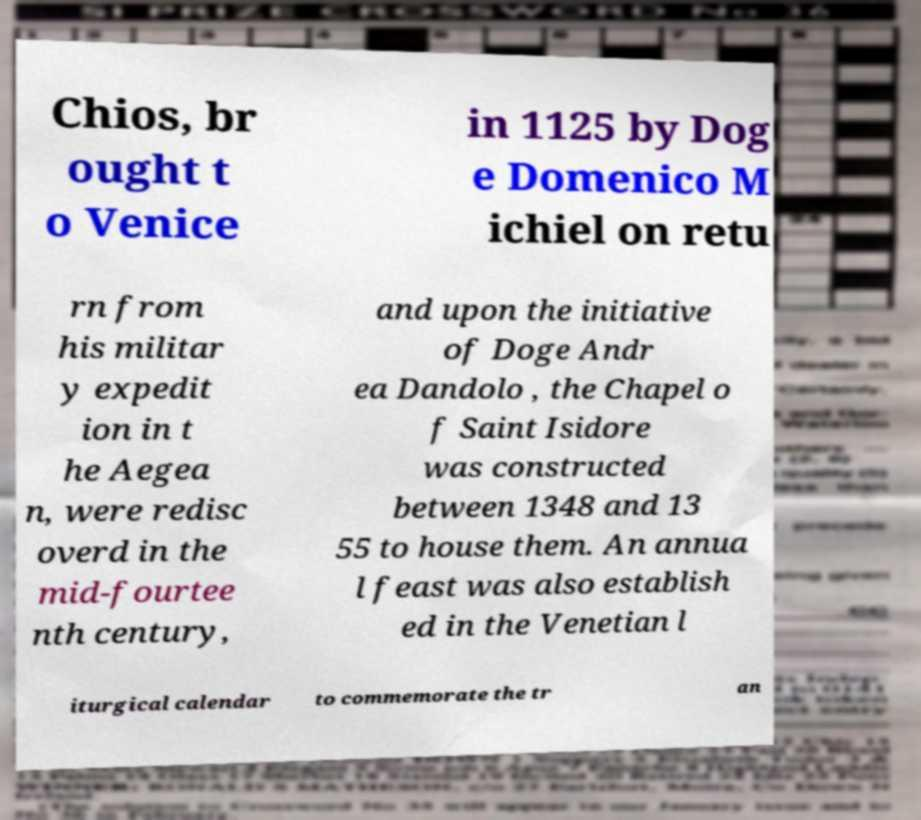Can you accurately transcribe the text from the provided image for me? Chios, br ought t o Venice in 1125 by Dog e Domenico M ichiel on retu rn from his militar y expedit ion in t he Aegea n, were redisc overd in the mid-fourtee nth century, and upon the initiative of Doge Andr ea Dandolo , the Chapel o f Saint Isidore was constructed between 1348 and 13 55 to house them. An annua l feast was also establish ed in the Venetian l iturgical calendar to commemorate the tr an 